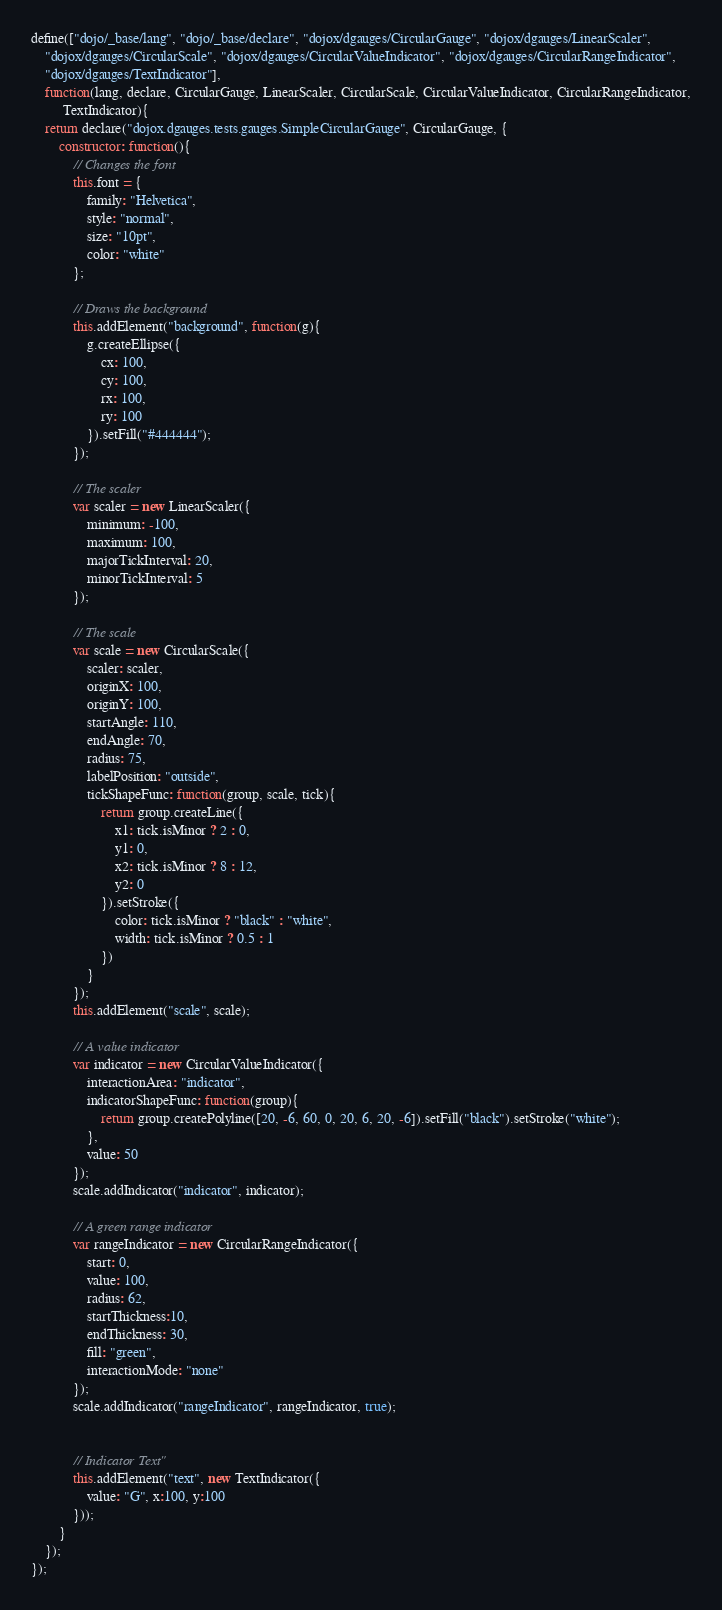Convert code to text. <code><loc_0><loc_0><loc_500><loc_500><_JavaScript_>define(["dojo/_base/lang", "dojo/_base/declare", "dojox/dgauges/CircularGauge", "dojox/dgauges/LinearScaler",
	"dojox/dgauges/CircularScale", "dojox/dgauges/CircularValueIndicator", "dojox/dgauges/CircularRangeIndicator",
	"dojox/dgauges/TextIndicator"],
	function(lang, declare, CircularGauge, LinearScaler, CircularScale, CircularValueIndicator, CircularRangeIndicator,
		 TextIndicator){
	return declare("dojox.dgauges.tests.gauges.SimpleCircularGauge", CircularGauge, {
		constructor: function(){
			// Changes the font
			this.font = {
				family: "Helvetica",
				style: "normal",
				size: "10pt",
				color: "white"
			};
			
			// Draws the background
			this.addElement("background", function(g){
				g.createEllipse({
					cx: 100,
					cy: 100,
					rx: 100,
					ry: 100
				}).setFill("#444444");
			});
			
			// The scaler
			var scaler = new LinearScaler({
				minimum: -100,
				maximum: 100,
				majorTickInterval: 20,
				minorTickInterval: 5
			});
			
			// The scale
			var scale = new CircularScale({
				scaler: scaler,
				originX: 100,
				originY: 100,
				startAngle: 110,
				endAngle: 70,
				radius: 75,
				labelPosition: "outside",
				tickShapeFunc: function(group, scale, tick){
					return group.createLine({
						x1: tick.isMinor ? 2 : 0,
						y1: 0,
						x2: tick.isMinor ? 8 : 12,
						y2: 0
					}).setStroke({
						color: tick.isMinor ? "black" : "white",
						width: tick.isMinor ? 0.5 : 1
					})
				}
			});
			this.addElement("scale", scale);
			
			// A value indicator
			var indicator = new CircularValueIndicator({
				interactionArea: "indicator",
				indicatorShapeFunc: function(group){
					return group.createPolyline([20, -6, 60, 0, 20, 6, 20, -6]).setFill("black").setStroke("white");
				},
				value: 50
			});
			scale.addIndicator("indicator", indicator);
			
			// A green range indicator
			var rangeIndicator = new CircularRangeIndicator({
				start: 0,
				value: 100,
				radius: 62,
				startThickness:10,
				endThickness: 30,
				fill: "green",
				interactionMode: "none"
			});
			scale.addIndicator("rangeIndicator", rangeIndicator, true);
			
			
			// Indicator Text"
			this.addElement("text", new TextIndicator({
				value: "G", x:100, y:100
			}));
		}	
	});
});
</code> 